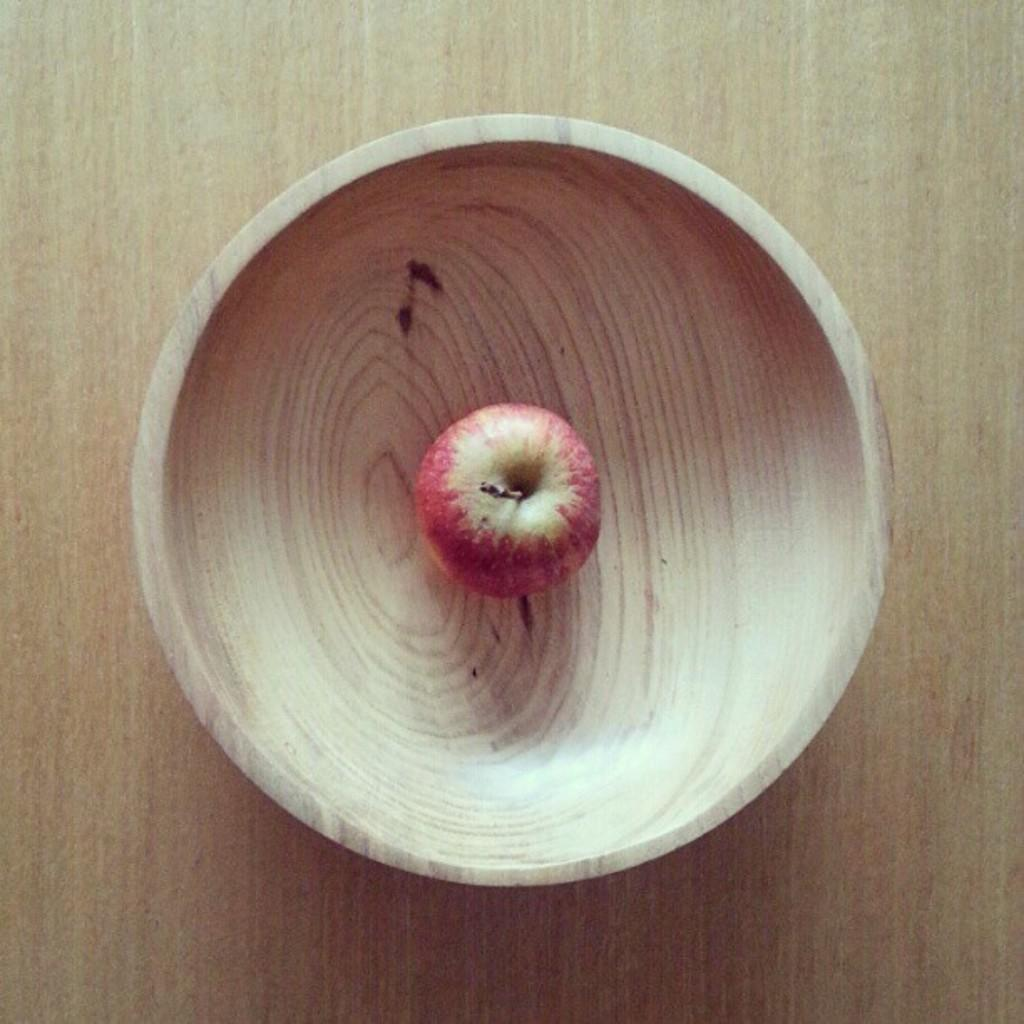What is in the bowl that is visible in the image? There is an apple in the bowl in the image. Where is the bowl located in the image? The bowl is placed on a table in the image. How does the apple produce smoke in the image? The apple does not produce smoke in the image; there is no smoke present. 